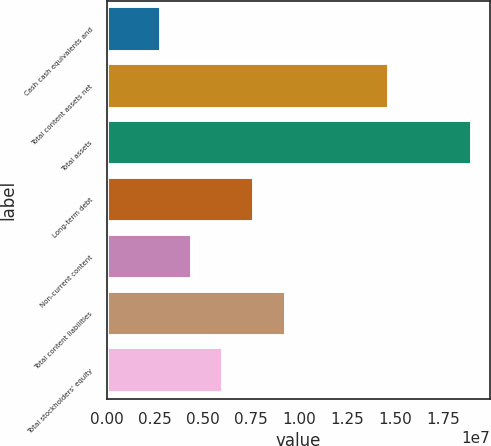Convert chart to OTSL. <chart><loc_0><loc_0><loc_500><loc_500><bar_chart><fcel>Cash cash equivalents and<fcel>Total content assets net<fcel>Total assets<fcel>Long-term debt<fcel>Non-current content<fcel>Total content liabilities<fcel>Total stockholders' equity<nl><fcel>2.8228e+06<fcel>1.4682e+07<fcel>1.90127e+07<fcel>7.67978e+06<fcel>4.44179e+06<fcel>9.29877e+06<fcel>6.06078e+06<nl></chart> 